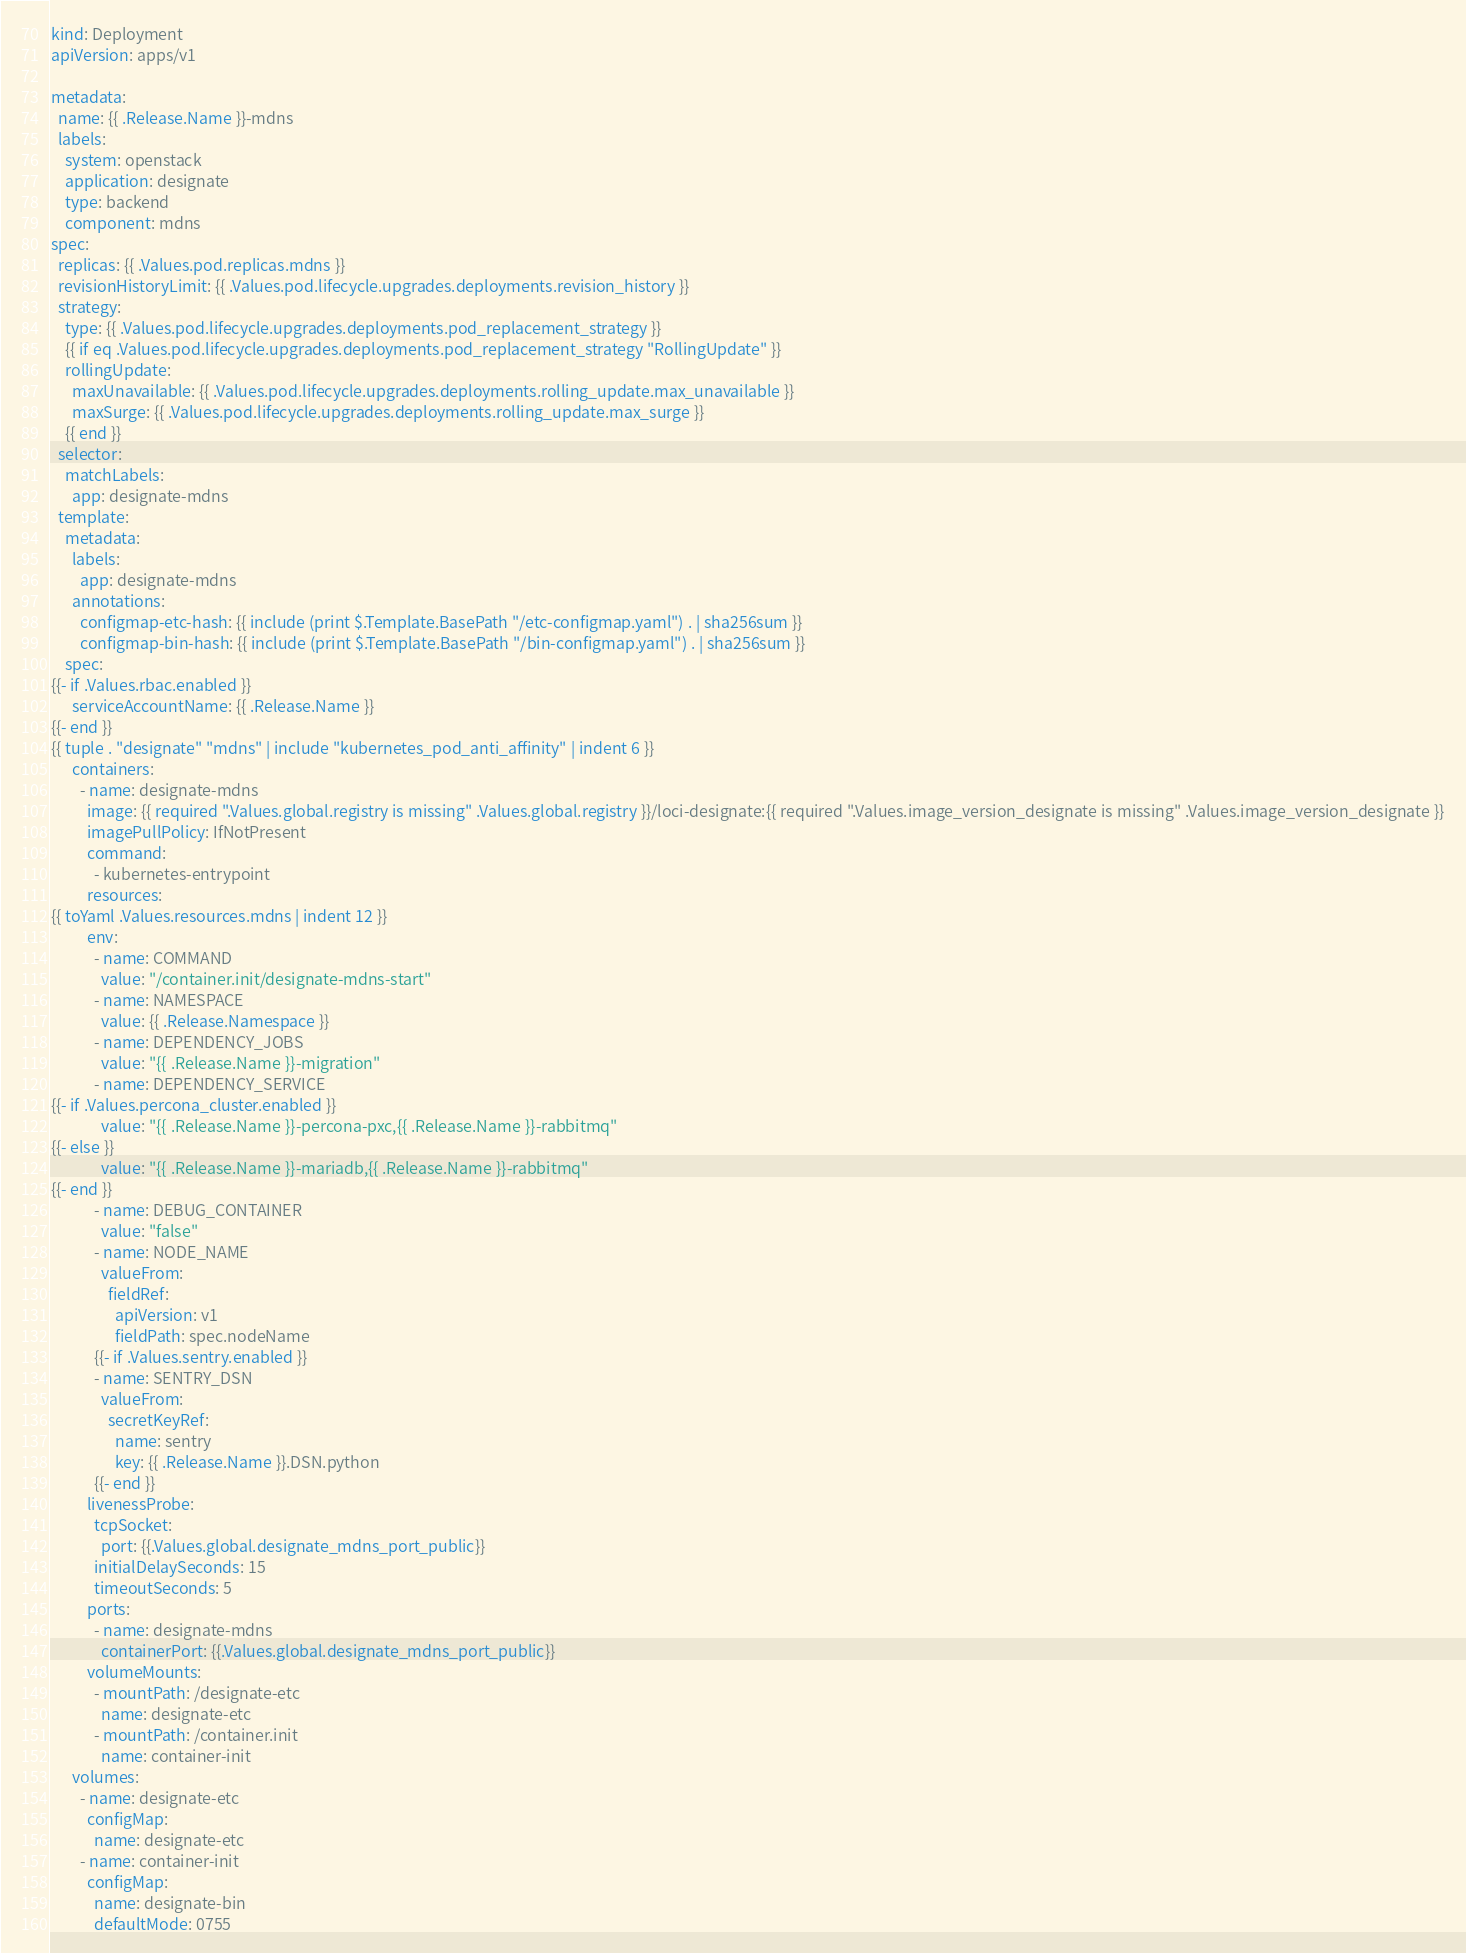Convert code to text. <code><loc_0><loc_0><loc_500><loc_500><_YAML_>kind: Deployment
apiVersion: apps/v1

metadata:
  name: {{ .Release.Name }}-mdns
  labels:
    system: openstack
    application: designate
    type: backend
    component: mdns
spec:
  replicas: {{ .Values.pod.replicas.mdns }}
  revisionHistoryLimit: {{ .Values.pod.lifecycle.upgrades.deployments.revision_history }}
  strategy:
    type: {{ .Values.pod.lifecycle.upgrades.deployments.pod_replacement_strategy }}
    {{ if eq .Values.pod.lifecycle.upgrades.deployments.pod_replacement_strategy "RollingUpdate" }}
    rollingUpdate:
      maxUnavailable: {{ .Values.pod.lifecycle.upgrades.deployments.rolling_update.max_unavailable }}
      maxSurge: {{ .Values.pod.lifecycle.upgrades.deployments.rolling_update.max_surge }}
    {{ end }}
  selector:
    matchLabels:
      app: designate-mdns
  template:
    metadata:
      labels:
        app: designate-mdns
      annotations:
        configmap-etc-hash: {{ include (print $.Template.BasePath "/etc-configmap.yaml") . | sha256sum }}
        configmap-bin-hash: {{ include (print $.Template.BasePath "/bin-configmap.yaml") . | sha256sum }}
    spec:
{{- if .Values.rbac.enabled }}
      serviceAccountName: {{ .Release.Name }}
{{- end }}
{{ tuple . "designate" "mdns" | include "kubernetes_pod_anti_affinity" | indent 6 }}
      containers:
        - name: designate-mdns
          image: {{ required ".Values.global.registry is missing" .Values.global.registry }}/loci-designate:{{ required ".Values.image_version_designate is missing" .Values.image_version_designate }}
          imagePullPolicy: IfNotPresent
          command:
            - kubernetes-entrypoint
          resources:
{{ toYaml .Values.resources.mdns | indent 12 }}
          env:
            - name: COMMAND
              value: "/container.init/designate-mdns-start"
            - name: NAMESPACE
              value: {{ .Release.Namespace }}
            - name: DEPENDENCY_JOBS
              value: "{{ .Release.Name }}-migration"
            - name: DEPENDENCY_SERVICE
{{- if .Values.percona_cluster.enabled }}
              value: "{{ .Release.Name }}-percona-pxc,{{ .Release.Name }}-rabbitmq"
{{- else }}
              value: "{{ .Release.Name }}-mariadb,{{ .Release.Name }}-rabbitmq"
{{- end }}
            - name: DEBUG_CONTAINER
              value: "false"
            - name: NODE_NAME
              valueFrom:
                fieldRef:
                  apiVersion: v1
                  fieldPath: spec.nodeName
            {{- if .Values.sentry.enabled }}
            - name: SENTRY_DSN
              valueFrom:
                secretKeyRef:
                  name: sentry
                  key: {{ .Release.Name }}.DSN.python
            {{- end }}
          livenessProbe:
            tcpSocket:
              port: {{.Values.global.designate_mdns_port_public}}
            initialDelaySeconds: 15
            timeoutSeconds: 5
          ports:
            - name: designate-mdns
              containerPort: {{.Values.global.designate_mdns_port_public}}
          volumeMounts:
            - mountPath: /designate-etc
              name: designate-etc
            - mountPath: /container.init
              name: container-init
      volumes:
        - name: designate-etc
          configMap:
            name: designate-etc
        - name: container-init
          configMap:
            name: designate-bin
            defaultMode: 0755
</code> 